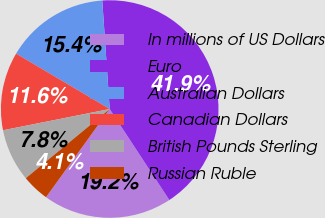Convert chart to OTSL. <chart><loc_0><loc_0><loc_500><loc_500><pie_chart><fcel>In millions of US Dollars<fcel>Euro<fcel>Australian Dollars<fcel>Canadian Dollars<fcel>British Pounds Sterling<fcel>Russian Ruble<nl><fcel>19.19%<fcel>41.86%<fcel>15.41%<fcel>11.63%<fcel>7.85%<fcel>4.07%<nl></chart> 